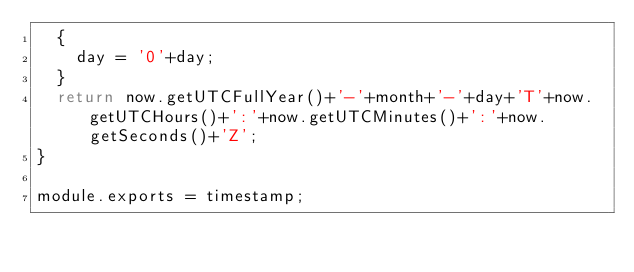<code> <loc_0><loc_0><loc_500><loc_500><_JavaScript_>	{
		day = '0'+day;
	}
	return now.getUTCFullYear()+'-'+month+'-'+day+'T'+now.getUTCHours()+':'+now.getUTCMinutes()+':'+now.getSeconds()+'Z';
}

module.exports = timestamp;</code> 